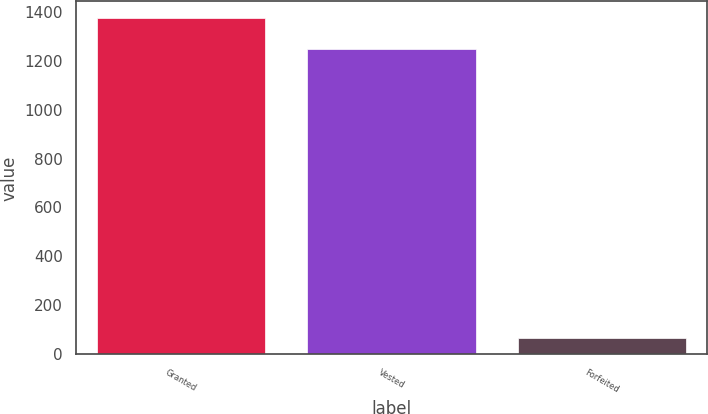Convert chart to OTSL. <chart><loc_0><loc_0><loc_500><loc_500><bar_chart><fcel>Granted<fcel>Vested<fcel>Forfeited<nl><fcel>1373.06<fcel>1248.3<fcel>65.5<nl></chart> 